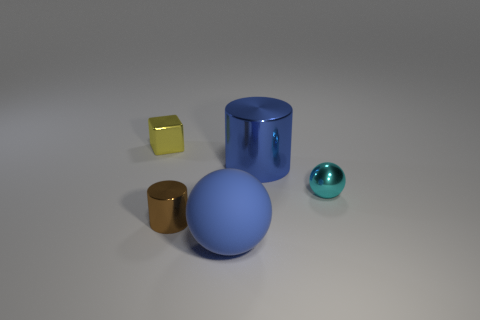Can you tell me the material that the yellow cube is likely made of? Based on the image, the yellow cube exhibits a glossy appearance indicating it could be made from a reflective material such as plastic or polished metal. 